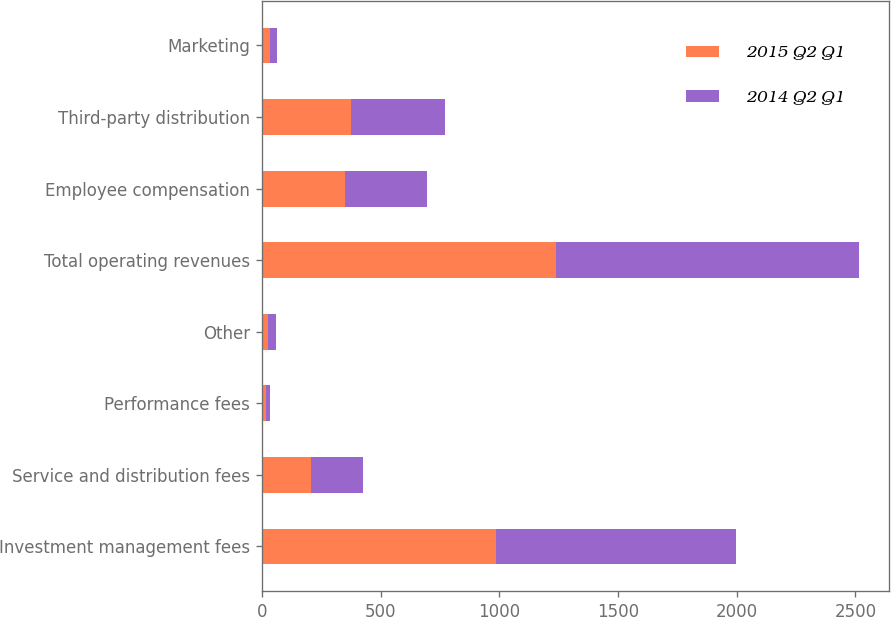<chart> <loc_0><loc_0><loc_500><loc_500><stacked_bar_chart><ecel><fcel>Investment management fees<fcel>Service and distribution fees<fcel>Performance fees<fcel>Other<fcel>Total operating revenues<fcel>Employee compensation<fcel>Third-party distribution<fcel>Marketing<nl><fcel>2015 Q2 Q1<fcel>987.1<fcel>207.6<fcel>16.8<fcel>28.2<fcel>1239.7<fcel>349.8<fcel>375.2<fcel>34.1<nl><fcel>2014 Q2 Q1<fcel>1009.5<fcel>217.7<fcel>16.8<fcel>32.7<fcel>1276.7<fcel>345.7<fcel>394.5<fcel>31.9<nl></chart> 